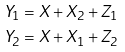Convert formula to latex. <formula><loc_0><loc_0><loc_500><loc_500>Y _ { 1 } & = X + X _ { 2 } + Z _ { 1 } \\ Y _ { 2 } & = X + X _ { 1 } + Z _ { 2 }</formula> 